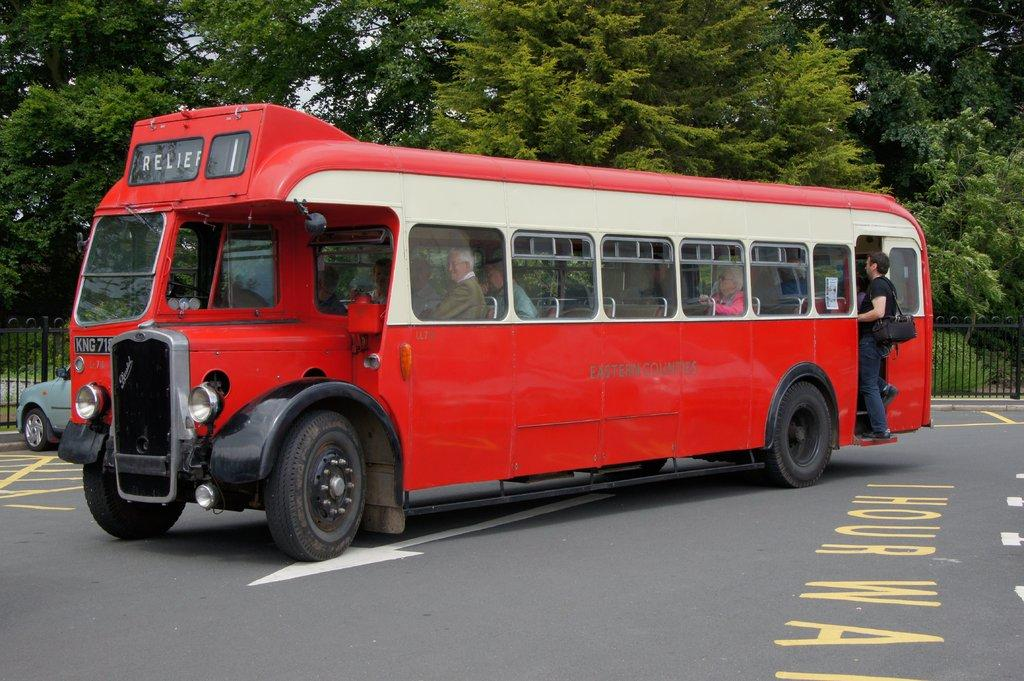What type of vehicle is on the road in the image? There is a bus on the road in the image. Can you describe the passengers in the bus? There are people inside the bus. What else can be seen in the background of the image? There is a car and railing visible in the background of the image. What type of natural elements are present in the image? There are trees visible in the image. Where is the tent located in the image? There is no tent present in the image. What type of cave can be seen in the background of the image? There is no cave present in the image. 